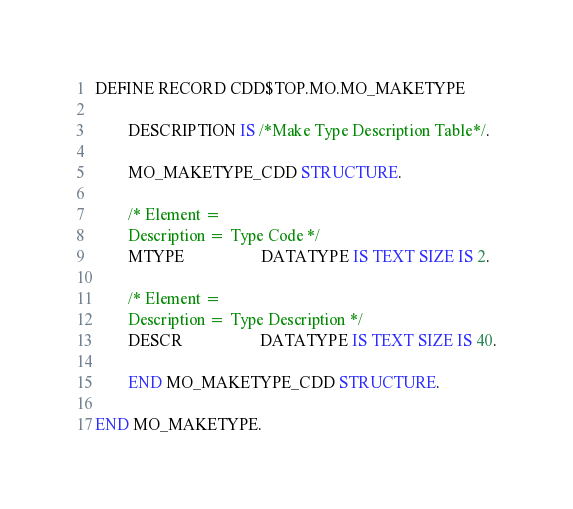Convert code to text. <code><loc_0><loc_0><loc_500><loc_500><_SQL_>DEFINE RECORD CDD$TOP.MO.MO_MAKETYPE

        DESCRIPTION IS /*Make Type Description Table*/.

        MO_MAKETYPE_CDD STRUCTURE.

        /* Element =
        Description = Type Code */
        MTYPE                   DATATYPE IS TEXT SIZE IS 2.

        /* Element =
        Description = Type Description */
        DESCR                   DATATYPE IS TEXT SIZE IS 40.

        END MO_MAKETYPE_CDD STRUCTURE.

END MO_MAKETYPE.
</code> 